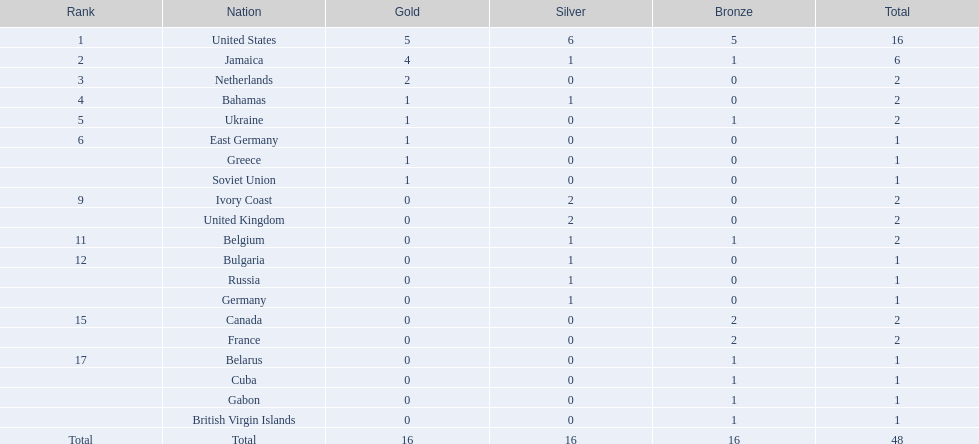In which country were the most medals awarded? United States. What was the total number of medals the united states received? 16. What is the greatest number of medals won by a country (following 16)? 6. Which country had a total of 6 medals? Jamaica. 